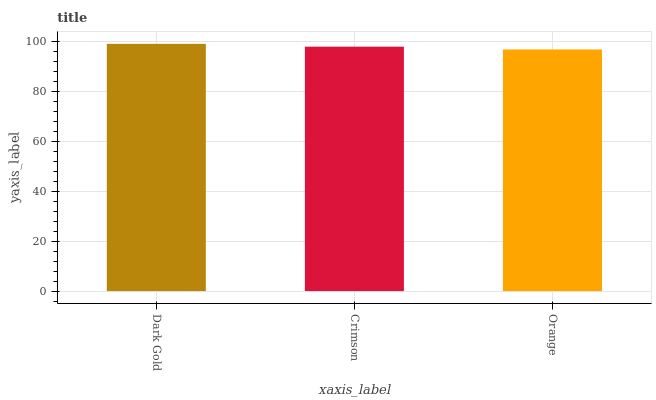Is Crimson the minimum?
Answer yes or no. No. Is Crimson the maximum?
Answer yes or no. No. Is Dark Gold greater than Crimson?
Answer yes or no. Yes. Is Crimson less than Dark Gold?
Answer yes or no. Yes. Is Crimson greater than Dark Gold?
Answer yes or no. No. Is Dark Gold less than Crimson?
Answer yes or no. No. Is Crimson the high median?
Answer yes or no. Yes. Is Crimson the low median?
Answer yes or no. Yes. Is Orange the high median?
Answer yes or no. No. Is Orange the low median?
Answer yes or no. No. 